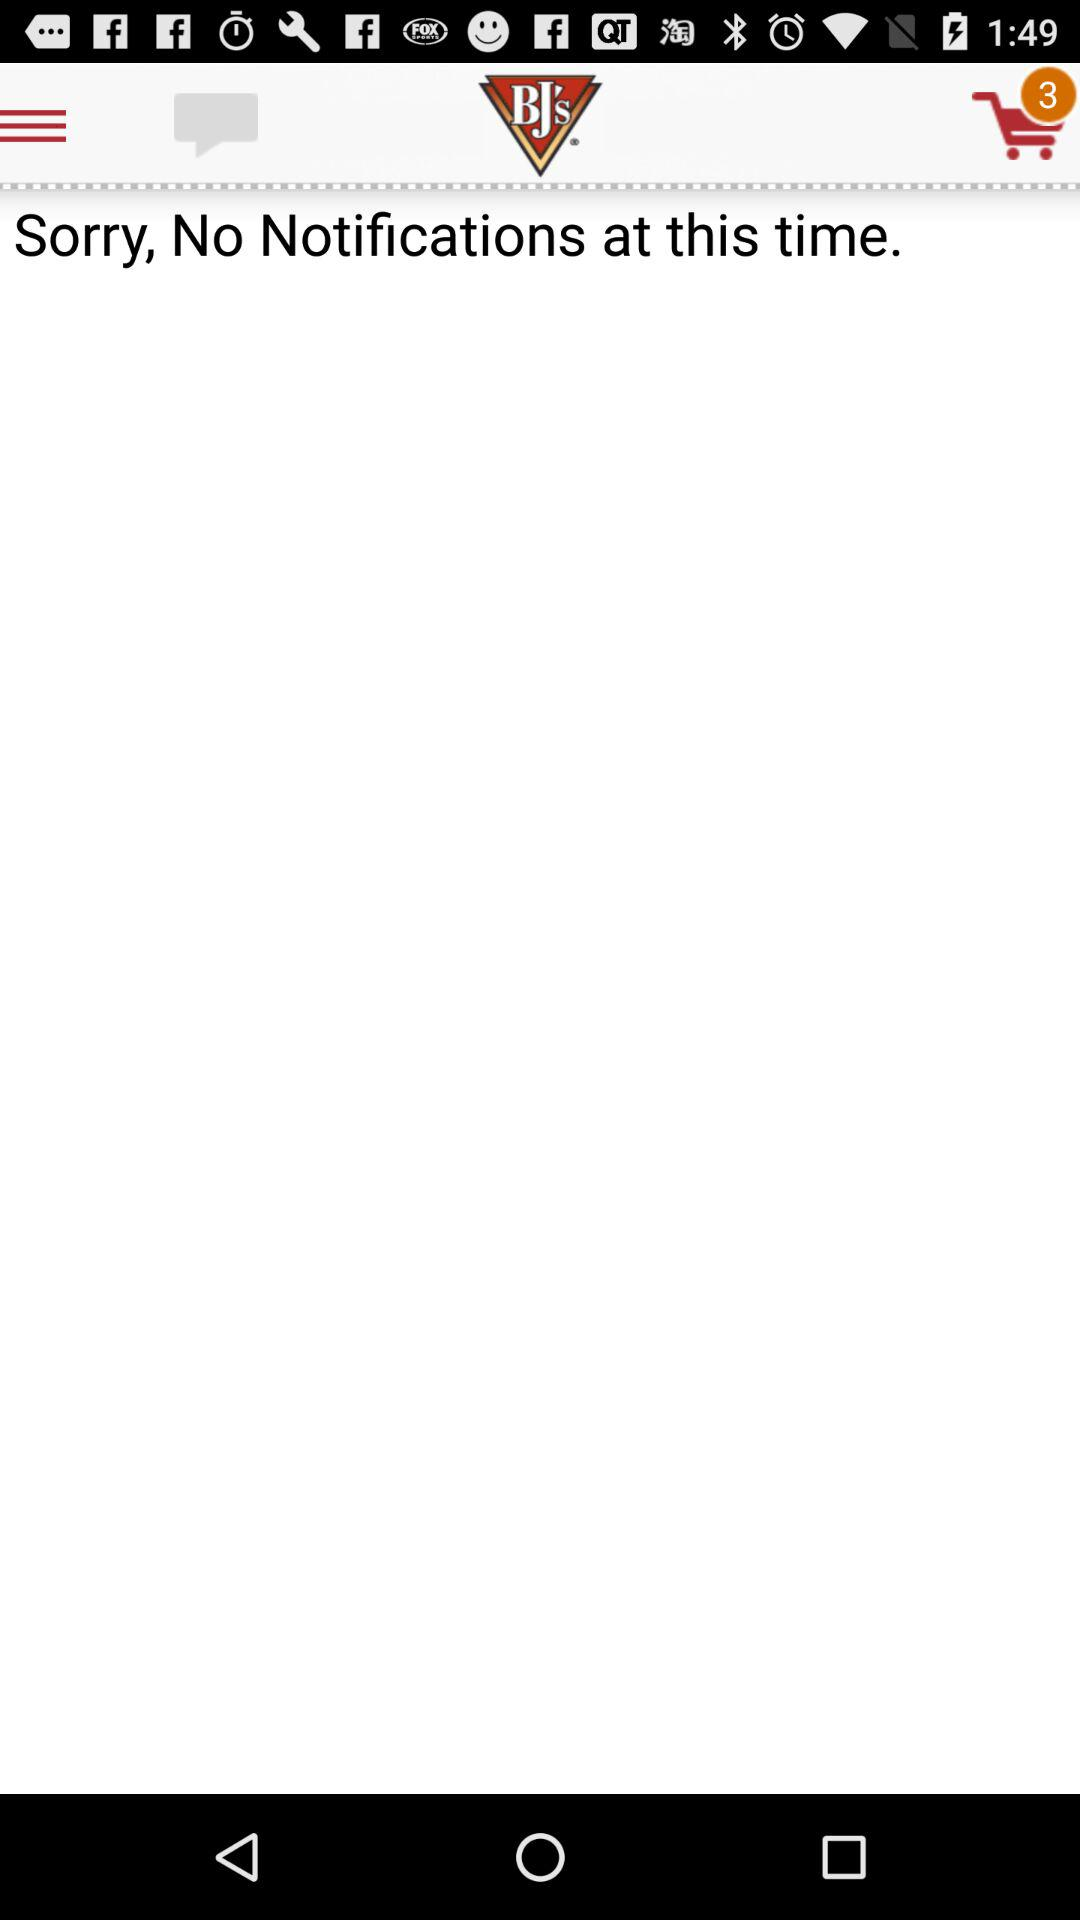Are there any notifications? There are "No" notifications. 